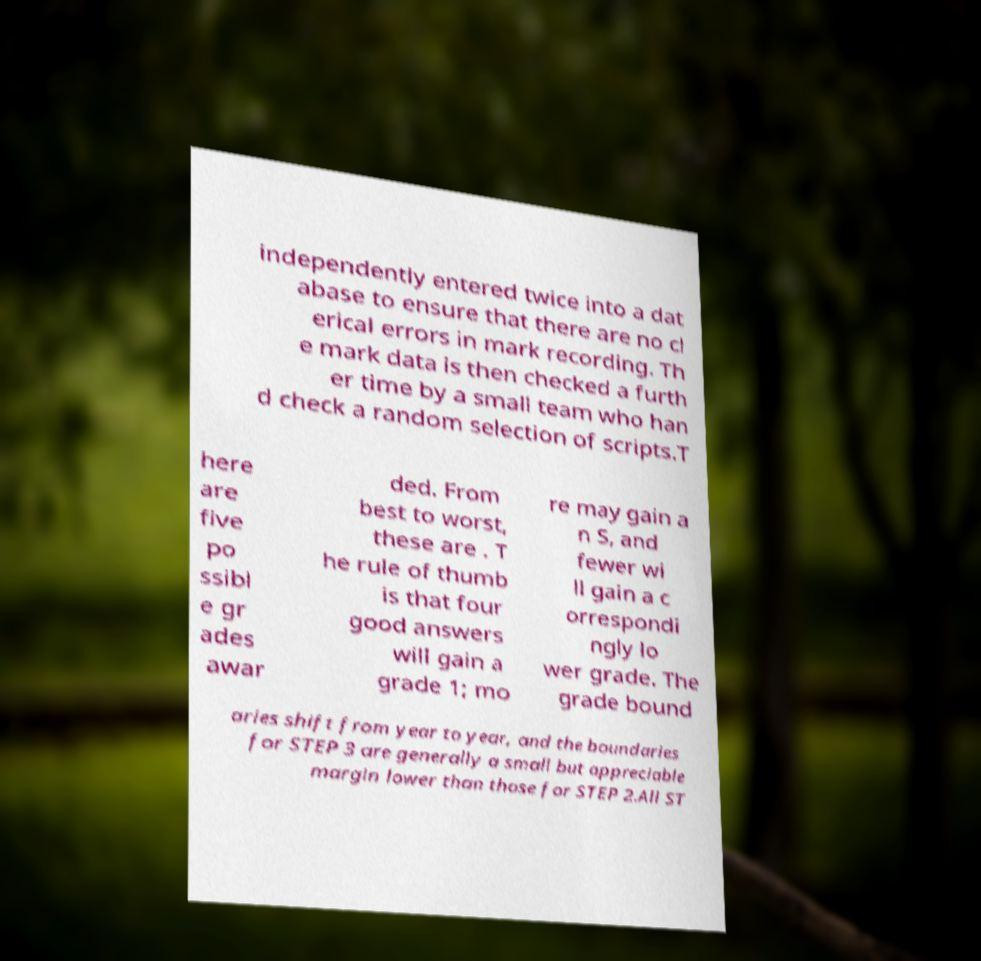What messages or text are displayed in this image? I need them in a readable, typed format. independently entered twice into a dat abase to ensure that there are no cl erical errors in mark recording. Th e mark data is then checked a furth er time by a small team who han d check a random selection of scripts.T here are five po ssibl e gr ades awar ded. From best to worst, these are . T he rule of thumb is that four good answers will gain a grade 1; mo re may gain a n S, and fewer wi ll gain a c orrespondi ngly lo wer grade. The grade bound aries shift from year to year, and the boundaries for STEP 3 are generally a small but appreciable margin lower than those for STEP 2.All ST 